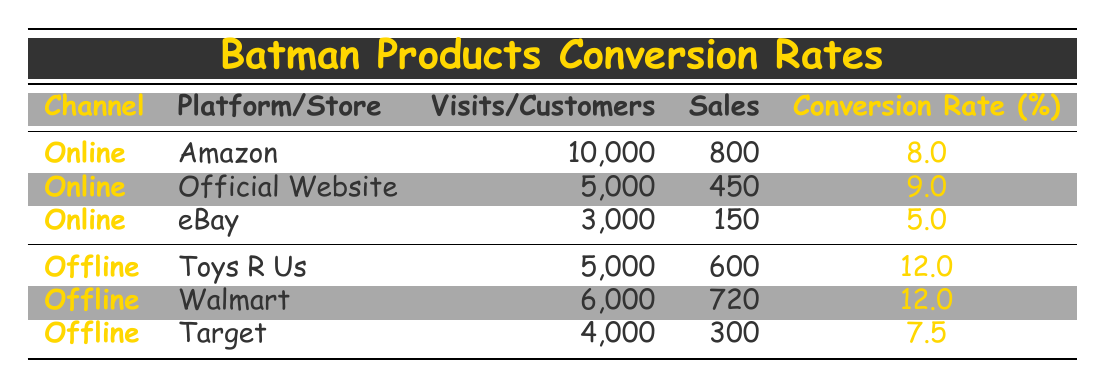What is the conversion rate for sales on Amazon? The table indicates that the conversion rate for sales on Amazon, under the Online channel, is 8.0 percent.
Answer: 8.0 Which offline store has the highest conversion rate? By examining the offline stores listed, Toys R Us and Walmart both have the highest conversion rates at 12.0 percent.
Answer: Toys R Us and Walmart What is the total number of visits for all online platforms combined? Adding the total visits from Amazon (10,000), Official Website (5,000), and eBay (3,000), we get 10,000 + 5,000 + 3,000 = 18,000 total visits.
Answer: 18,000 What is the average conversion rate across all offline stores? The conversion rates for Toys R Us (12.0), Walmart (12.0), and Target (7.5) total to 12.0 + 12.0 + 7.5 = 31.5. Dividing by 3 (the number of offline stores) gives 31.5 / 3 = 10.5 percent average conversion rate.
Answer: 10.5 Is the conversion rate for Official Website higher than that for eBay? The table shows that the conversion rate for the Official Website is 9.0 percent, while eBay has a conversion rate of 5.0 percent, making the statement true.
Answer: Yes How many sales were made through the Target store? The table states that Target had a total of 300 sales.
Answer: 300 Which online platform has the lowest conversion rate and what is that rate? The examination of the online platforms reveals that eBay has the lowest conversion rate at 5.0 percent.
Answer: 5.0 What is the difference in conversion rates between the highest and lowest performing channel types? The highest conversion rate among offline channels is 12.0, while the lowest in online is 5.0. The difference is 12.0 - 5.0 = 7.0 percent, indicating offline sales conversion is significantly better.
Answer: 7.0 